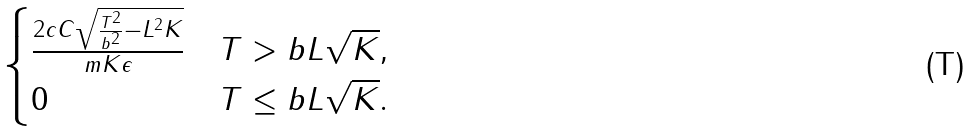Convert formula to latex. <formula><loc_0><loc_0><loc_500><loc_500>\begin{cases} \frac { 2 c C \sqrt { \frac { T ^ { 2 } } { b ^ { 2 } } - L ^ { 2 } K } } { m K \epsilon } & T > b L \sqrt { K } , \\ 0 & T \leq b L \sqrt { K } . \end{cases}</formula> 